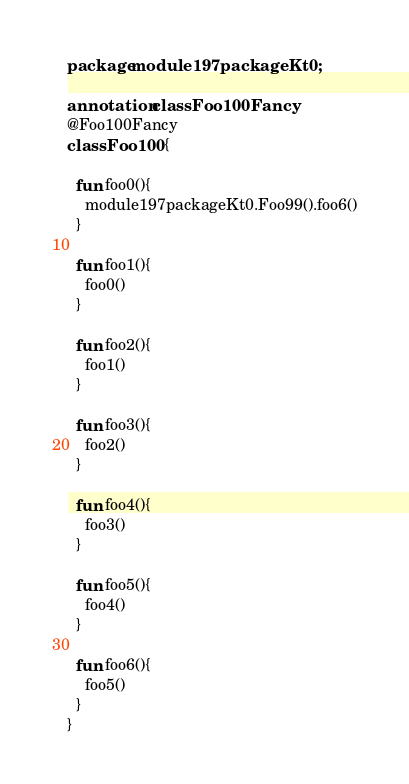<code> <loc_0><loc_0><loc_500><loc_500><_Kotlin_>package module197packageKt0;

annotation class Foo100Fancy
@Foo100Fancy
class Foo100 {

  fun foo0(){
    module197packageKt0.Foo99().foo6()
  }

  fun foo1(){
    foo0()
  }

  fun foo2(){
    foo1()
  }

  fun foo3(){
    foo2()
  }

  fun foo4(){
    foo3()
  }

  fun foo5(){
    foo4()
  }

  fun foo6(){
    foo5()
  }
}</code> 